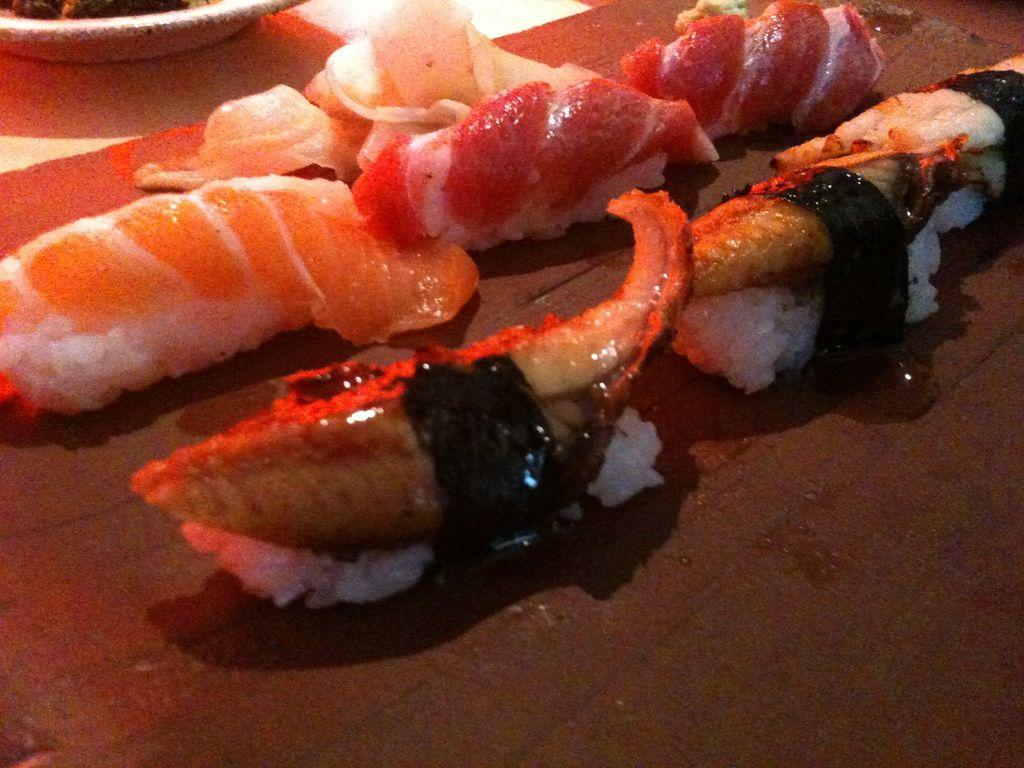What is present on the platform in the image? There are food items on a platform in the image. Can you describe the item in the plate on the platform? There is an item in a plate on the platform in the image, but the specific food item cannot be determined from the provided facts. What type of copper material is used to make the airport in the image? There is no mention of copper or an airport in the image; it features food items on a platform. 